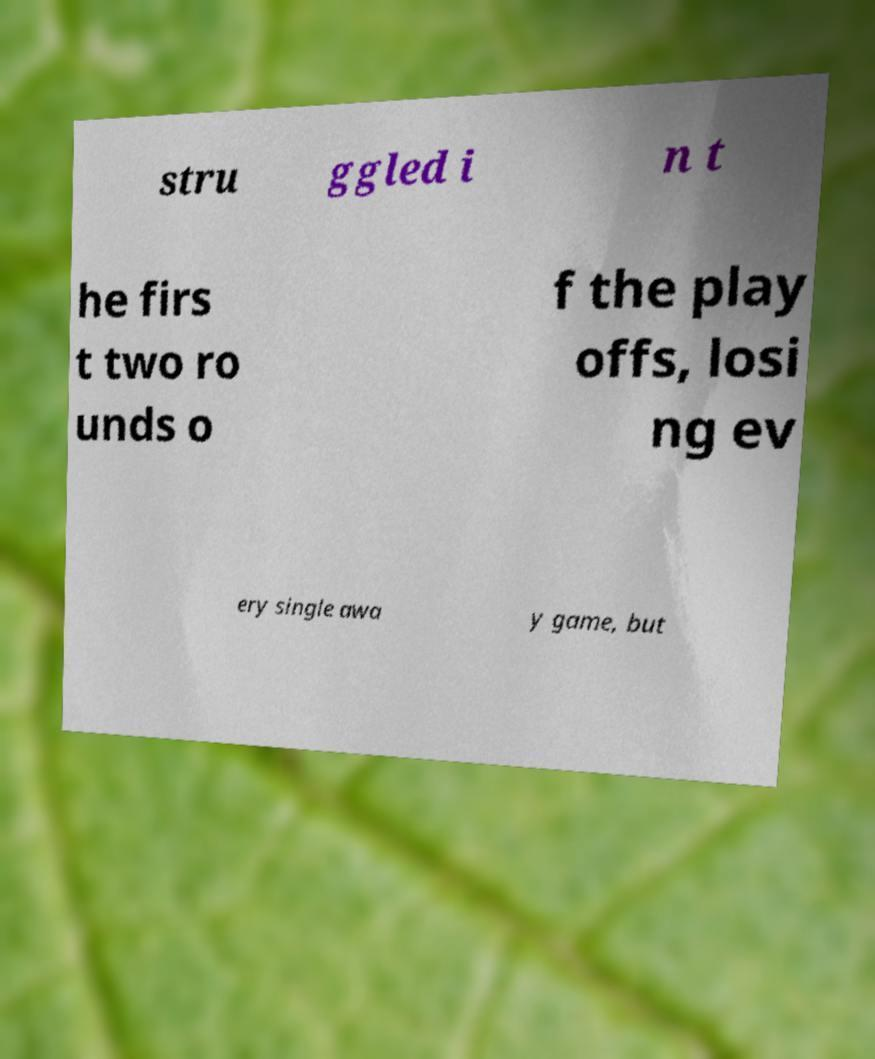Could you extract and type out the text from this image? stru ggled i n t he firs t two ro unds o f the play offs, losi ng ev ery single awa y game, but 